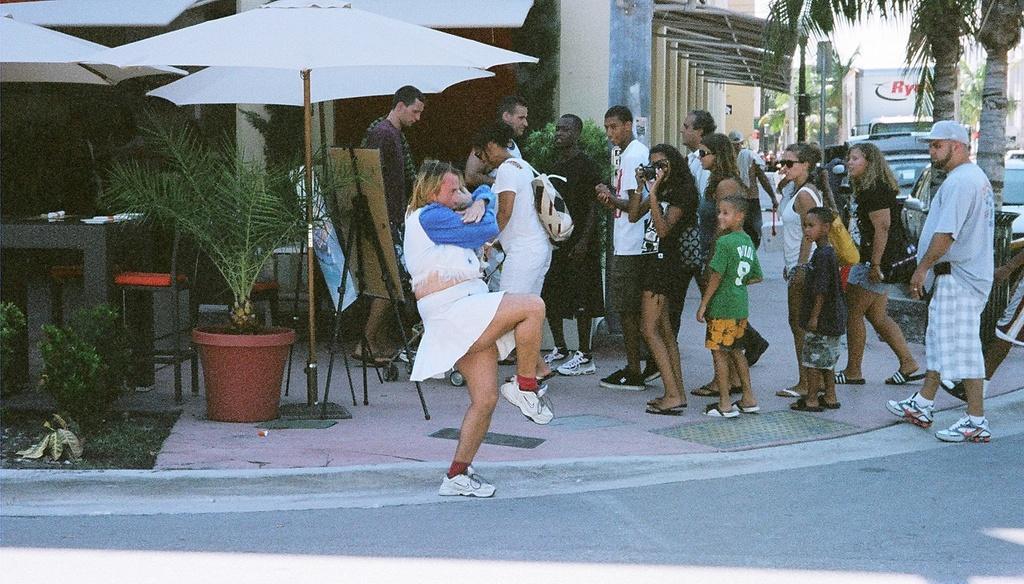In one or two sentences, can you explain what this image depicts? This is the picture of a place where we have a person on the road and to the side there are some other people, among them a lady is holding the camera and around there are some umbrellas, houses, trees, plants, poster and some other things around. 